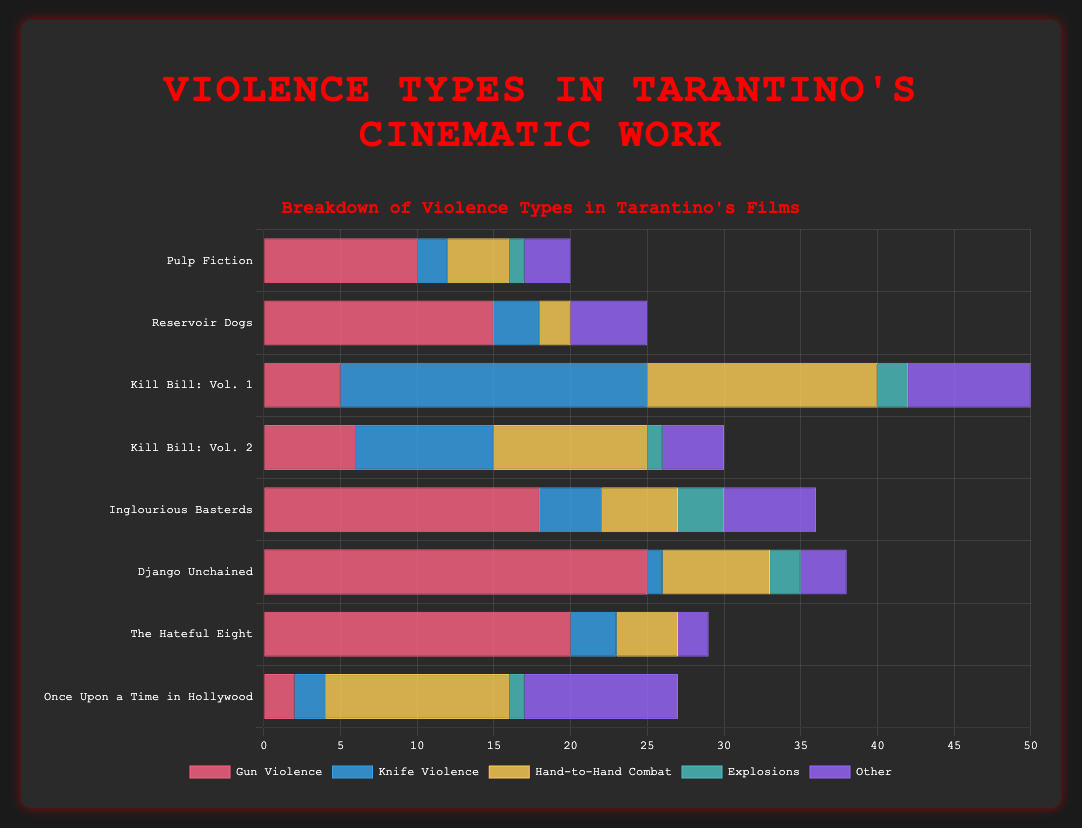Which movie has the highest number of 'Gun Violence' instances? By examining the lengths of the red bars representing 'Gun Violence' for each movie, we see that "Django Unchained" has the longest bar, indicating the highest number.
Answer: Django Unchained What is the total number of 'Knife Violence' instances across all movies? Sum up the 'Knife Violence' values for all movies: 2 (Pulp Fiction) + 3 (Reservoir Dogs) + 20 (Kill Bill: Vol. 1) + 9 (Kill Bill: Vol. 2) + 4 (Inglourious Basterds) + 1 (Django Unchained) + 3 (The Hateful Eight) + 2 (Once Upon a Time in Hollywood) = 44
Answer: 44 Which movie has the least amount of 'Hand-to-Hand Combat' and what is that amount? Look at the yellow bars representing 'Hand-to-Hand Combat'. Both "Reservoir Dogs" and "The Hateful Eight" have the shortest bars with a count of 2 and 4 respectively. Upon closer inspection, "Reservoir Dogs" has the least with 2 instances.
Answer: Reservoir Dogs, 2 How many more instances of 'Explosions' are there in "Inglourious Basterds" compared to "Pulp Fiction"? Subtract the 'Explosions' value for "Pulp Fiction" (1) from "Inglourious Basterds" (3): 3 - 1 = 2
Answer: 2 Which movie has the highest combined counts of 'Gun Violence' and 'Hand-to-Hand Combat'? Calculate the sum of 'Gun Violence' and 'Hand-to-Hand Combat' for each movie and compare: "Pulp Fiction" (10 + 4 = 14), "Reservoir Dogs" (15 + 2 = 17), "Kill Bill: Vol. 1" (5 + 15 = 20), "Kill Bill: Vol. 2" (6 + 10 = 16), "Inglourious Basterds" (18 + 5 = 23), "Django Unchained" (25 + 7 = 32), "The Hateful Eight" (20 + 4 = 24), "Once Upon a Time in Hollywood" (2 + 12 = 14). "Django Unchained" has the highest with 32.
Answer: Django Unchained Between "Kill Bill: Vol. 1" and "Kill Bill: Vol. 2", which has fewer 'Knife Violence' instances and by how many? Subtract the 'Knife Violence' value of "Kill Bill: Vol. 2" (9) from "Kill Bill: Vol. 1" (20): 20 - 9 = 11
Answer: Kill Bill: Vol. 2, by 11 What is the ratio of 'Gun Violence' in "Pulp Fiction" to "Once Upon a Time in Hollywood"? Divide the 'Gun Violence' value of "Pulp Fiction" (10) by "Once Upon a Time in Hollywood" (2): 10 / 2 = 5
Answer: 5:1 Which movie has the largest number of instances classified as 'Other'? Look at the purple bars representing 'Other'. "Once Upon a Time in Hollywood" has the longest bar indicating the highest number of instances with a count of 10.
Answer: Once Upon a Time in Hollywood How many instances of violence (all types) are there in "The Hateful Eight"? Sum all the violence types for "The Hateful Eight": 20 (Gun Violence) + 3 (Knife Violence) + 4 (Hand-to-Hand Combat) + 0 (Explosions) + 2 (Other) = 29
Answer: 29 What is the average number of 'Gun Violence' instances per movie? Sum up the 'Gun Violence' values for all movies and divide by the number of movies: (10 + 15 + 5 + 6 + 18 + 25 + 20 + 2) / 8 = 101 / 8 = 12.625
Answer: 12.625 